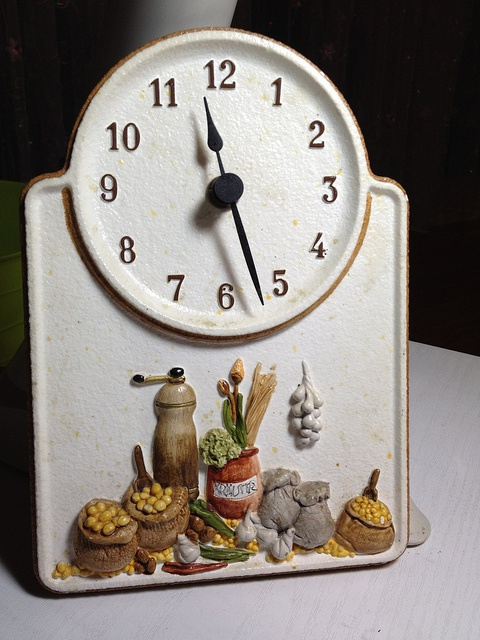Describe the objects in this image and their specific colors. I can see a clock in black, lightgray, and darkgray tones in this image. 